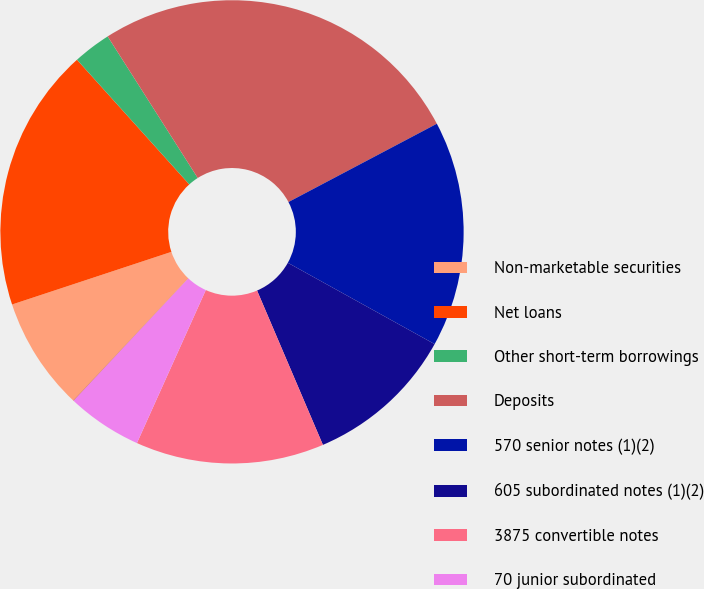<chart> <loc_0><loc_0><loc_500><loc_500><pie_chart><fcel>Non-marketable securities<fcel>Net loans<fcel>Other short-term borrowings<fcel>Deposits<fcel>570 senior notes (1)(2)<fcel>605 subordinated notes (1)(2)<fcel>3875 convertible notes<fcel>70 junior subordinated<fcel>Other long-term debt<nl><fcel>7.9%<fcel>18.41%<fcel>2.65%<fcel>26.29%<fcel>15.78%<fcel>10.53%<fcel>13.15%<fcel>5.27%<fcel>0.02%<nl></chart> 